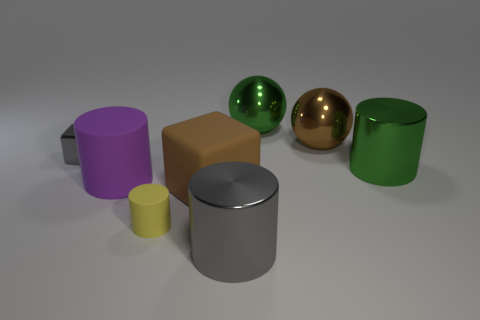Are there any objects that look the same in shape and color? No, each object in the image is uniquely colored and while some shapes are repeated, such as the cylinders, their sizes and colors vary. 